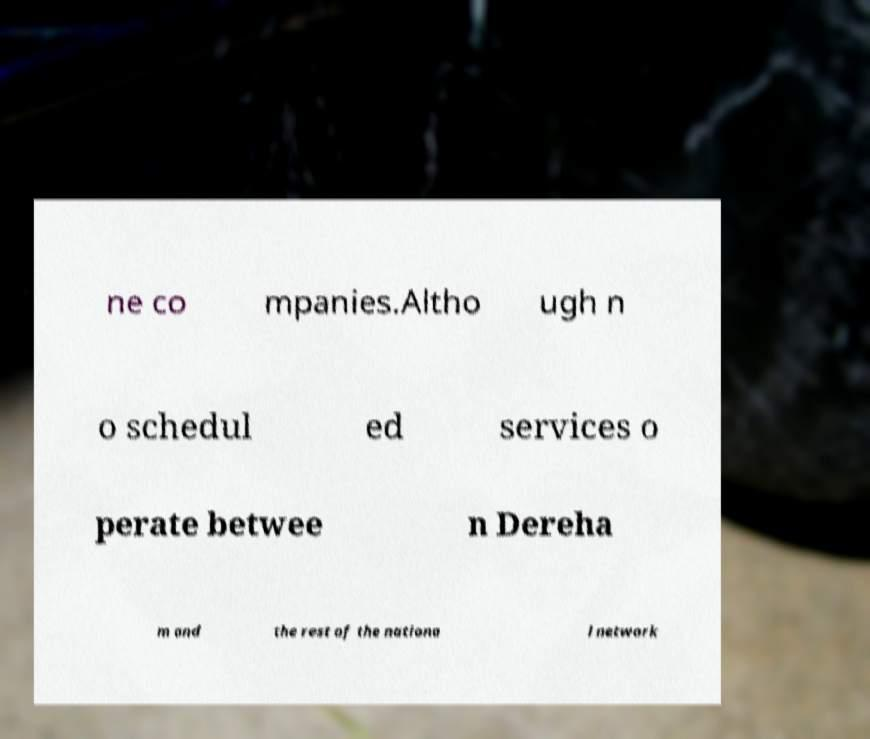What messages or text are displayed in this image? I need them in a readable, typed format. ne co mpanies.Altho ugh n o schedul ed services o perate betwee n Dereha m and the rest of the nationa l network 